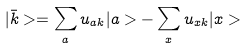Convert formula to latex. <formula><loc_0><loc_0><loc_500><loc_500>| \bar { k } > = \sum _ { a } u _ { a k } | a > - \sum _ { x } u _ { x k } | x ></formula> 